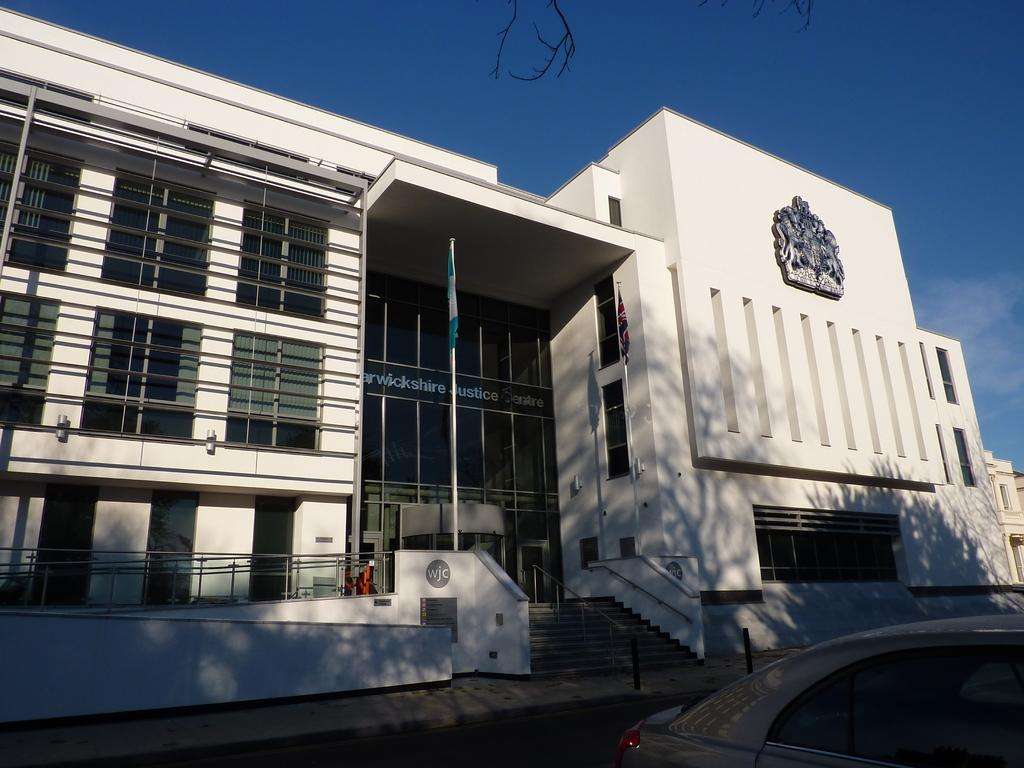What is on the path in the image? There is a vehicle on the path in the image. What can be seen behind the vehicle? There are buildings visible behind the vehicle. What part of the natural environment is visible in the image? The sky is visible in the image. What type of print can be seen on the vehicle in the image? There is no specific print visible on the vehicle in the image; it is not mentioned in the provided facts. 